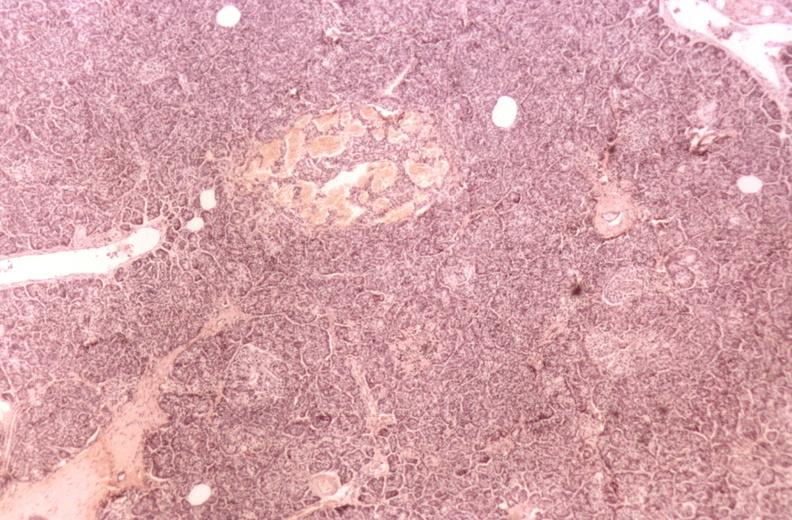s pancreas present?
Answer the question using a single word or phrase. Yes 